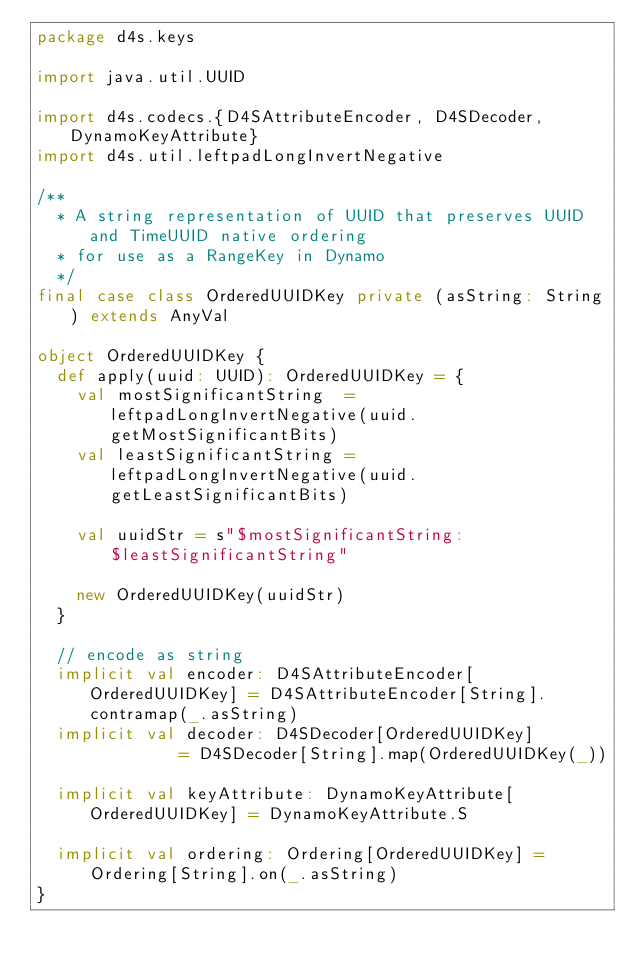Convert code to text. <code><loc_0><loc_0><loc_500><loc_500><_Scala_>package d4s.keys

import java.util.UUID

import d4s.codecs.{D4SAttributeEncoder, D4SDecoder, DynamoKeyAttribute}
import d4s.util.leftpadLongInvertNegative

/**
  * A string representation of UUID that preserves UUID and TimeUUID native ordering
  * for use as a RangeKey in Dynamo
  */
final case class OrderedUUIDKey private (asString: String) extends AnyVal

object OrderedUUIDKey {
  def apply(uuid: UUID): OrderedUUIDKey = {
    val mostSignificantString  = leftpadLongInvertNegative(uuid.getMostSignificantBits)
    val leastSignificantString = leftpadLongInvertNegative(uuid.getLeastSignificantBits)

    val uuidStr = s"$mostSignificantString:$leastSignificantString"

    new OrderedUUIDKey(uuidStr)
  }

  // encode as string
  implicit val encoder: D4SAttributeEncoder[OrderedUUIDKey] = D4SAttributeEncoder[String].contramap(_.asString)
  implicit val decoder: D4SDecoder[OrderedUUIDKey]          = D4SDecoder[String].map(OrderedUUIDKey(_))

  implicit val keyAttribute: DynamoKeyAttribute[OrderedUUIDKey] = DynamoKeyAttribute.S

  implicit val ordering: Ordering[OrderedUUIDKey] = Ordering[String].on(_.asString)
}
</code> 